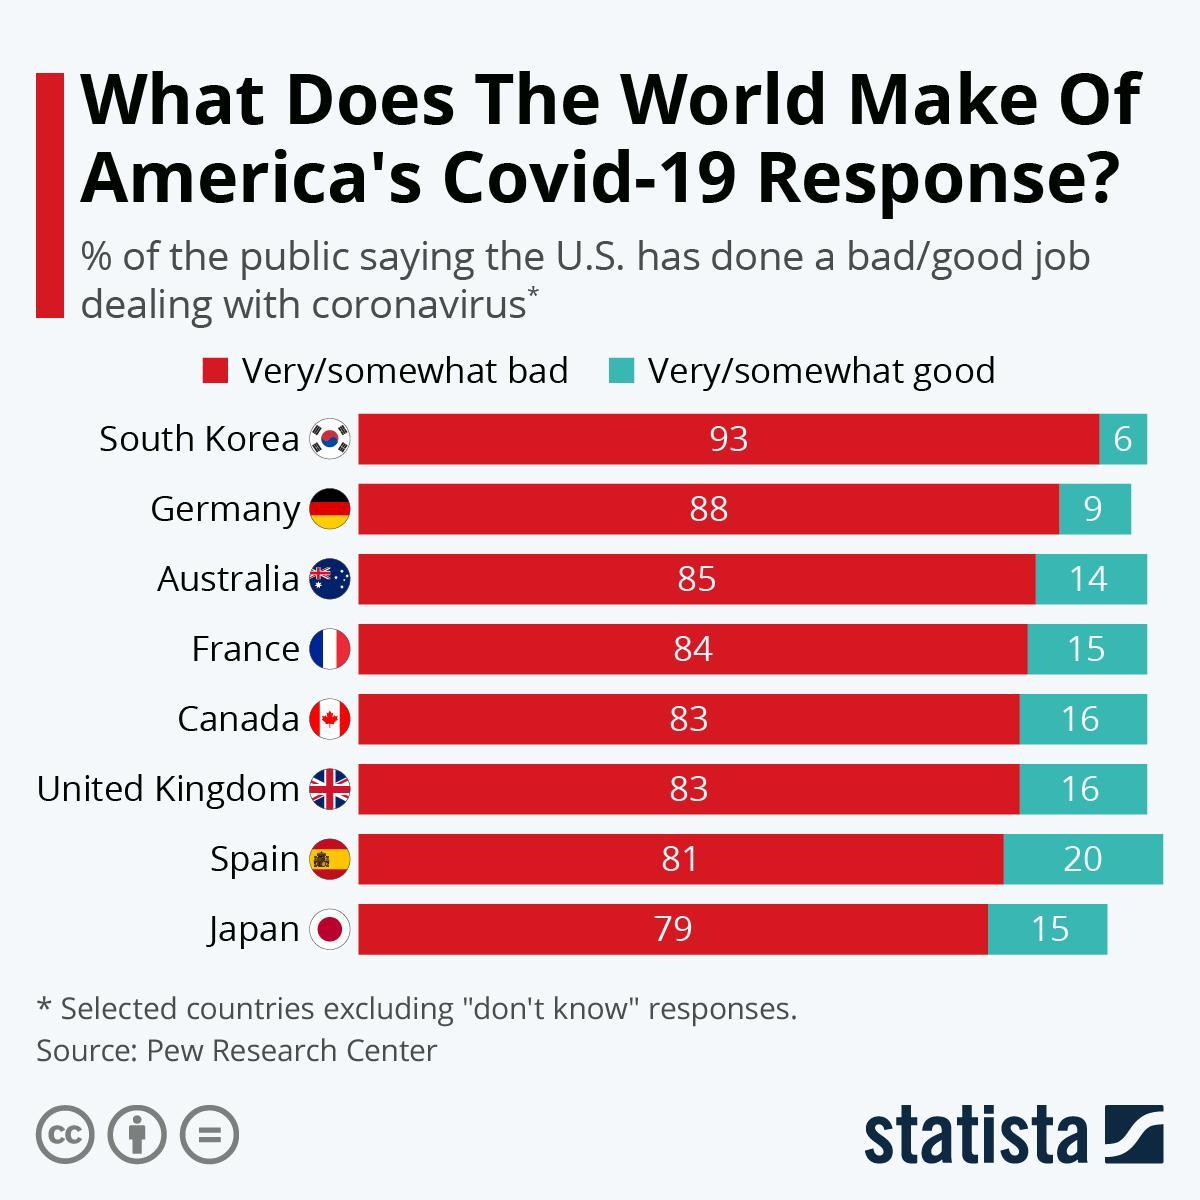What percentage of the public are saying that the U.S. has done a good job dealing with coronavirus in Canada?
Answer the question with a short phrase. 16 What percentage of the public are saying that the U.S. has done a bad job dealing with coronavirus in Germany? 88 What percentage of the public are saying that the U.S. has done a good job dealing with coronavirus in Spain? 20 What percentage of the public are saying that the U.S. has done a bad job dealing with coronavirus in France? 84 What percentage of the public are saying that the U.S. has done a bad job dealing with coronavirus in Japan? 79 What percentage of the public are saying that the U.S. has done a good job dealing with coronavirus in Australia? 14 